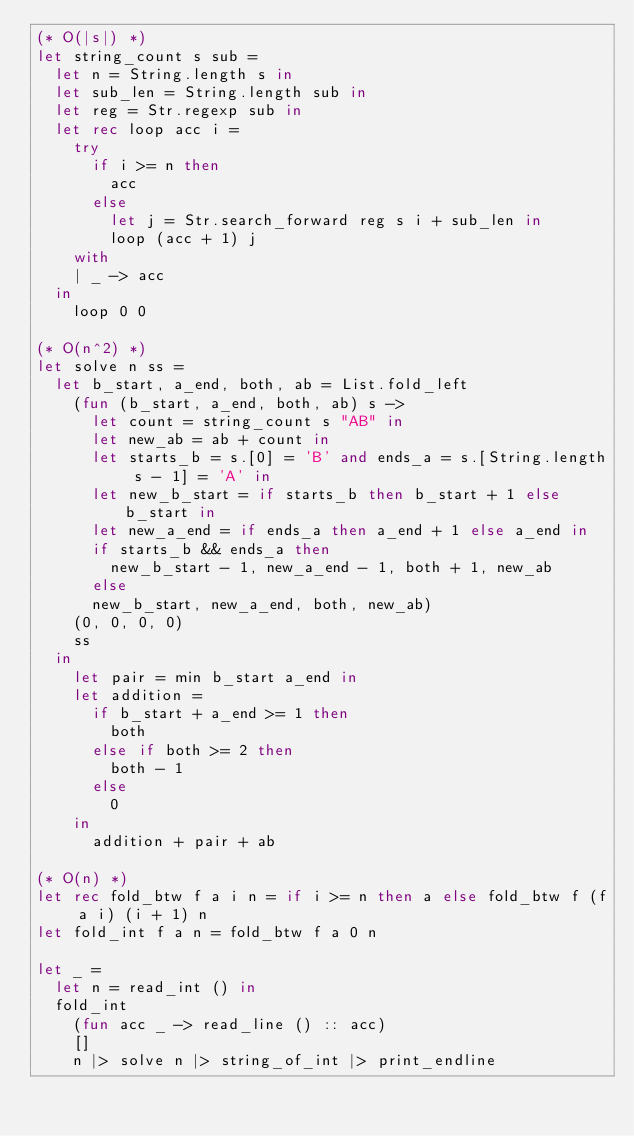Convert code to text. <code><loc_0><loc_0><loc_500><loc_500><_OCaml_>(* O(|s|) *)
let string_count s sub =
  let n = String.length s in
  let sub_len = String.length sub in
  let reg = Str.regexp sub in
  let rec loop acc i =
    try
      if i >= n then
        acc
      else
        let j = Str.search_forward reg s i + sub_len in
        loop (acc + 1) j
    with
    | _ -> acc
  in
    loop 0 0

(* O(n^2) *)
let solve n ss =
  let b_start, a_end, both, ab = List.fold_left
    (fun (b_start, a_end, both, ab) s ->
      let count = string_count s "AB" in
      let new_ab = ab + count in
      let starts_b = s.[0] = 'B' and ends_a = s.[String.length s - 1] = 'A' in
      let new_b_start = if starts_b then b_start + 1 else b_start in
      let new_a_end = if ends_a then a_end + 1 else a_end in
      if starts_b && ends_a then
        new_b_start - 1, new_a_end - 1, both + 1, new_ab
      else
      new_b_start, new_a_end, both, new_ab)
    (0, 0, 0, 0)
    ss
  in
    let pair = min b_start a_end in
    let addition =
      if b_start + a_end >= 1 then
        both
      else if both >= 2 then
        both - 1
      else
        0
    in
      addition + pair + ab

(* O(n) *)
let rec fold_btw f a i n = if i >= n then a else fold_btw f (f a i) (i + 1) n
let fold_int f a n = fold_btw f a 0 n

let _ =
  let n = read_int () in
  fold_int
    (fun acc _ -> read_line () :: acc)
    []
    n |> solve n |> string_of_int |> print_endline</code> 